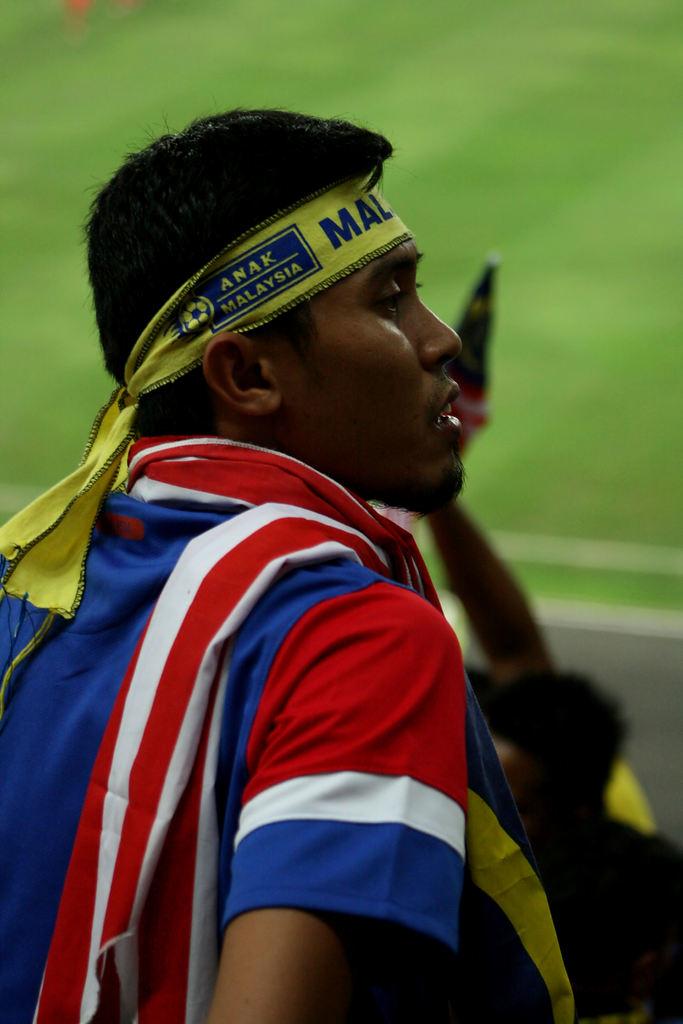Is he from malaysia?
Provide a succinct answer. Yes. What is the word written above malaysia?
Provide a succinct answer. Anak. 